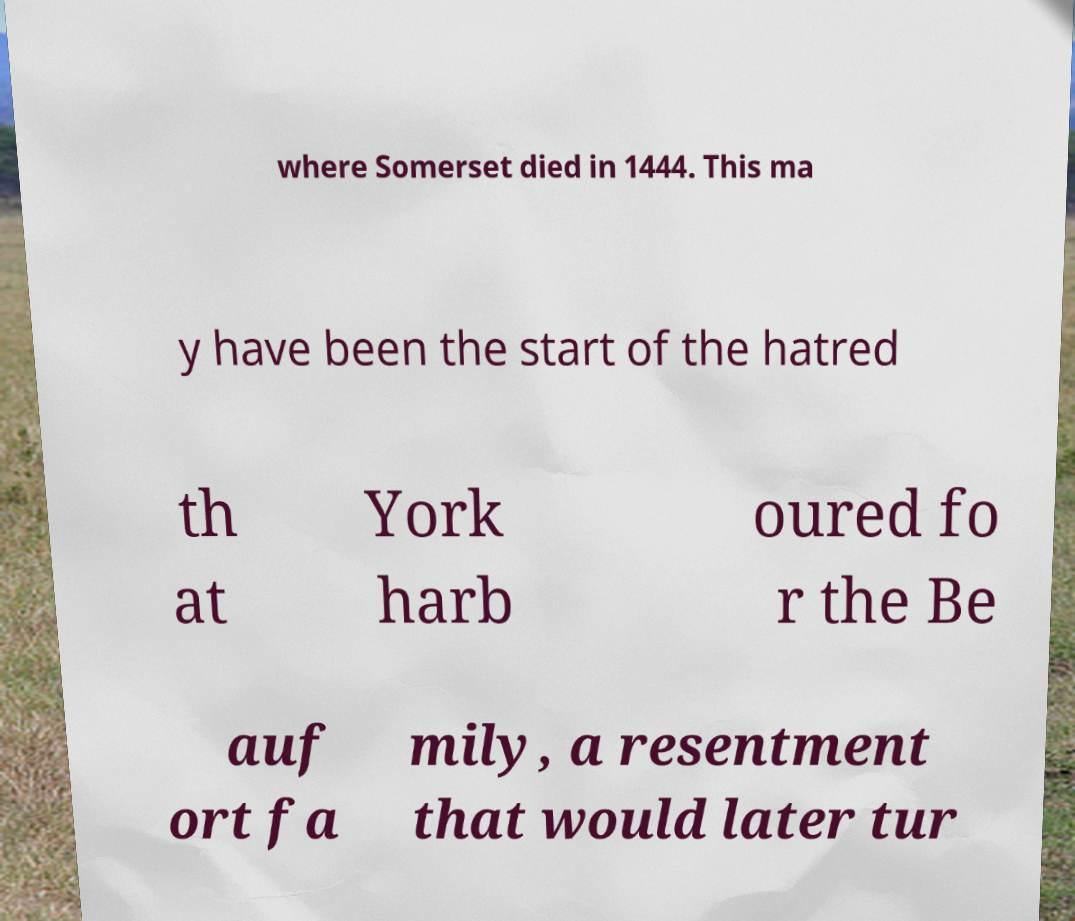Can you accurately transcribe the text from the provided image for me? where Somerset died in 1444. This ma y have been the start of the hatred th at York harb oured fo r the Be auf ort fa mily, a resentment that would later tur 